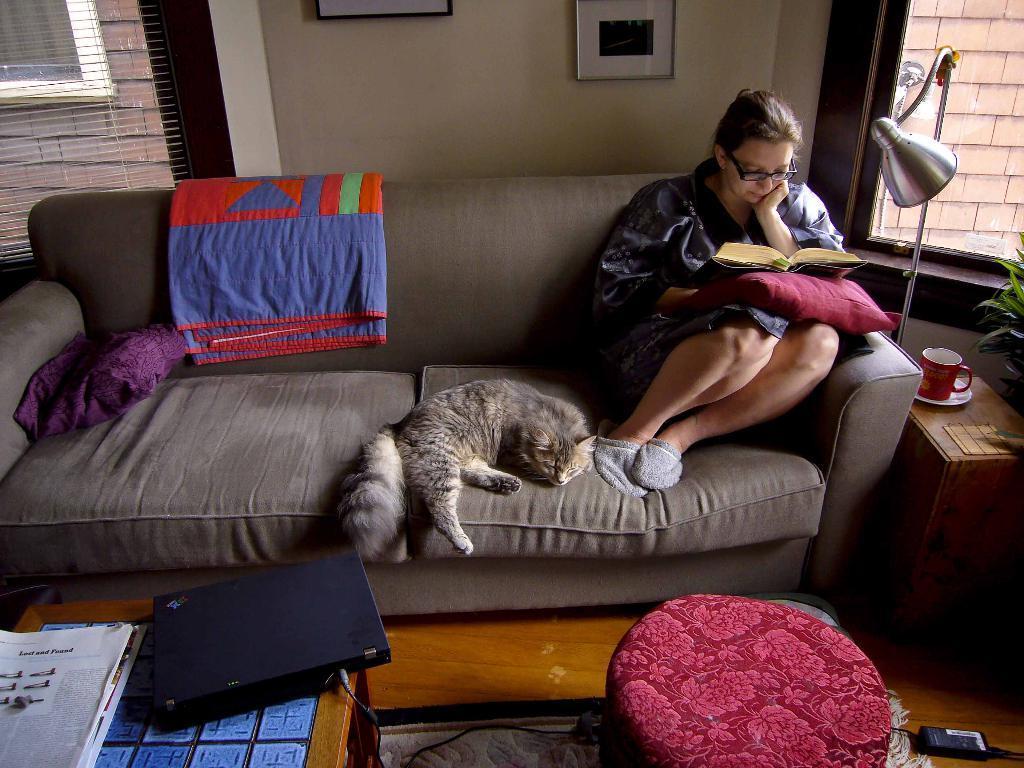Could you give a brief overview of what you see in this image? In the image we can see there is a woman who is sitting on sofa with a cat and on the table there is a laptop. 